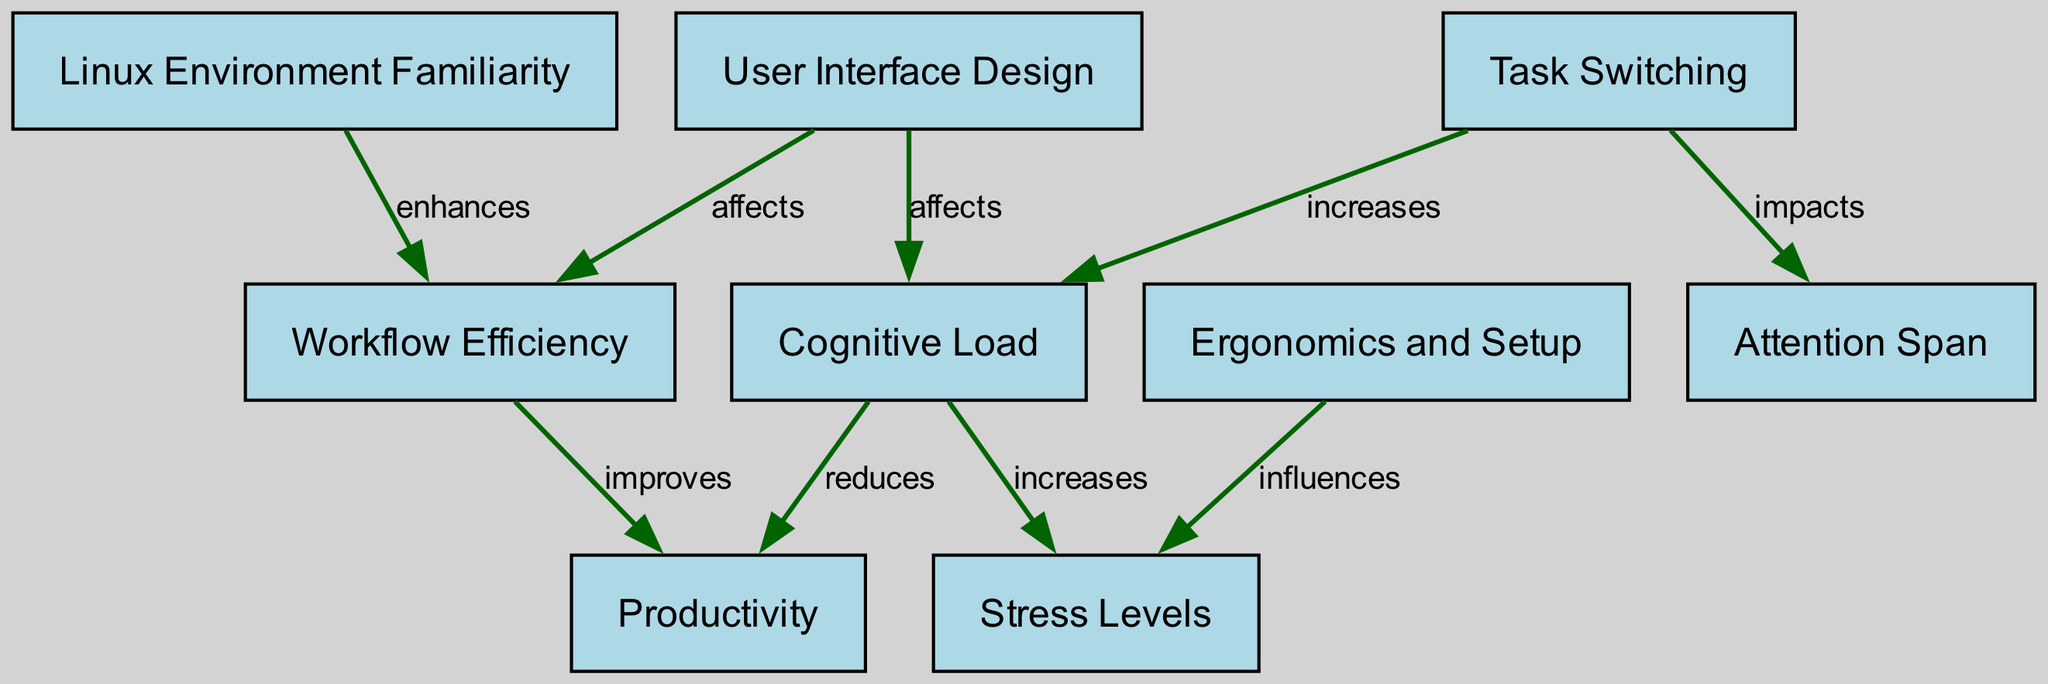What are the total nodes in the diagram? By counting the distinct nodes listed in the diagram, we find there are 9 nodes: User Interface Design, Cognitive Load, Task Switching, Productivity, Stress Levels, Workflow Efficiency, Linux Environment Familiarity, Attention Span, and Ergonomics and Setup.
Answer: 9 Which node is directly influenced by the User Interface Design? The edges in the diagram indicate that User Interface Design directly affects both Cognitive Load and Workflow Efficiency. Thus, both nodes are influenced. However, since the question requests only one, it will focus on Cognitive Load as it plays a key role in the psychological aspect.
Answer: Cognitive Load What is the effect of task switching on cognitive load? The diagram clearly states that task switching increases cognitive load, making it a direct relationship based on the edge connecting these two nodes with the description of their connection.
Answer: Increases Name one factor that influences stress levels. According to the edges in the diagram, both Cognitive Load and Ergonomics influence stress levels. Thus, if asked for one factor, we can refer to Ergonomics as it addresses the comfort of the user setup, a relevant aspect for stress.
Answer: Ergonomics What impact does Linux Environment Familiarity have on workflow efficiency? The diagram shows that Linux Environment Familiarity enhances workflow efficiency, as represented by the connecting edge that clearly states this effect.
Answer: Enhances How does cognitive load affect productivity? The diagram illustrates a negative relationship where cognitive load reduces productivity, indicated by the relationship between these two nodes. This means that higher cognitive load likely leads to decreased productivity levels.
Answer: Reduces What is the relationship between task switching and attention span? The edge connecting task switching and attention span shows it impacts attention span, making this an essential relationship where task switching has a potential negative effect on how focused one can remain during tasks.
Answer: Impacts Which node has a direct connection to multiple nodes in the diagram? Cognitive Load has direct edges connecting to both Productivity and Stress Levels, making it a central node that influences multiple aspects within the diagram. This multiple linkage signifies its importance in the context of multitasking.
Answer: Cognitive Load 